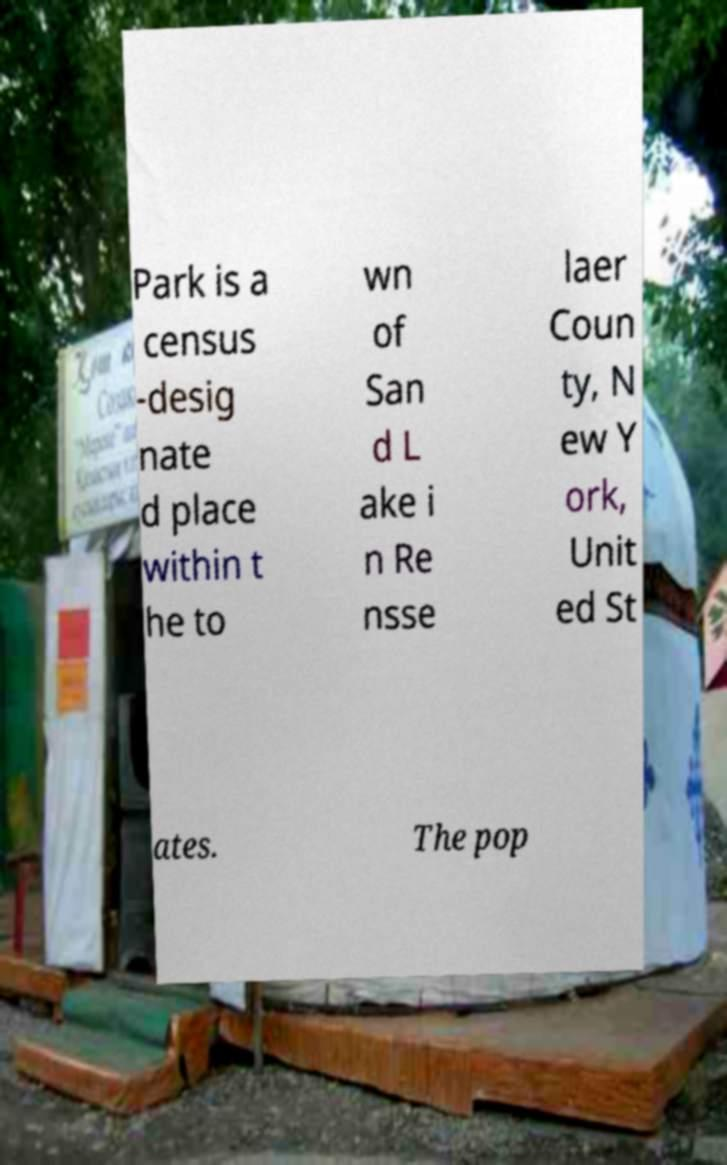Can you read and provide the text displayed in the image?This photo seems to have some interesting text. Can you extract and type it out for me? Park is a census -desig nate d place within t he to wn of San d L ake i n Re nsse laer Coun ty, N ew Y ork, Unit ed St ates. The pop 